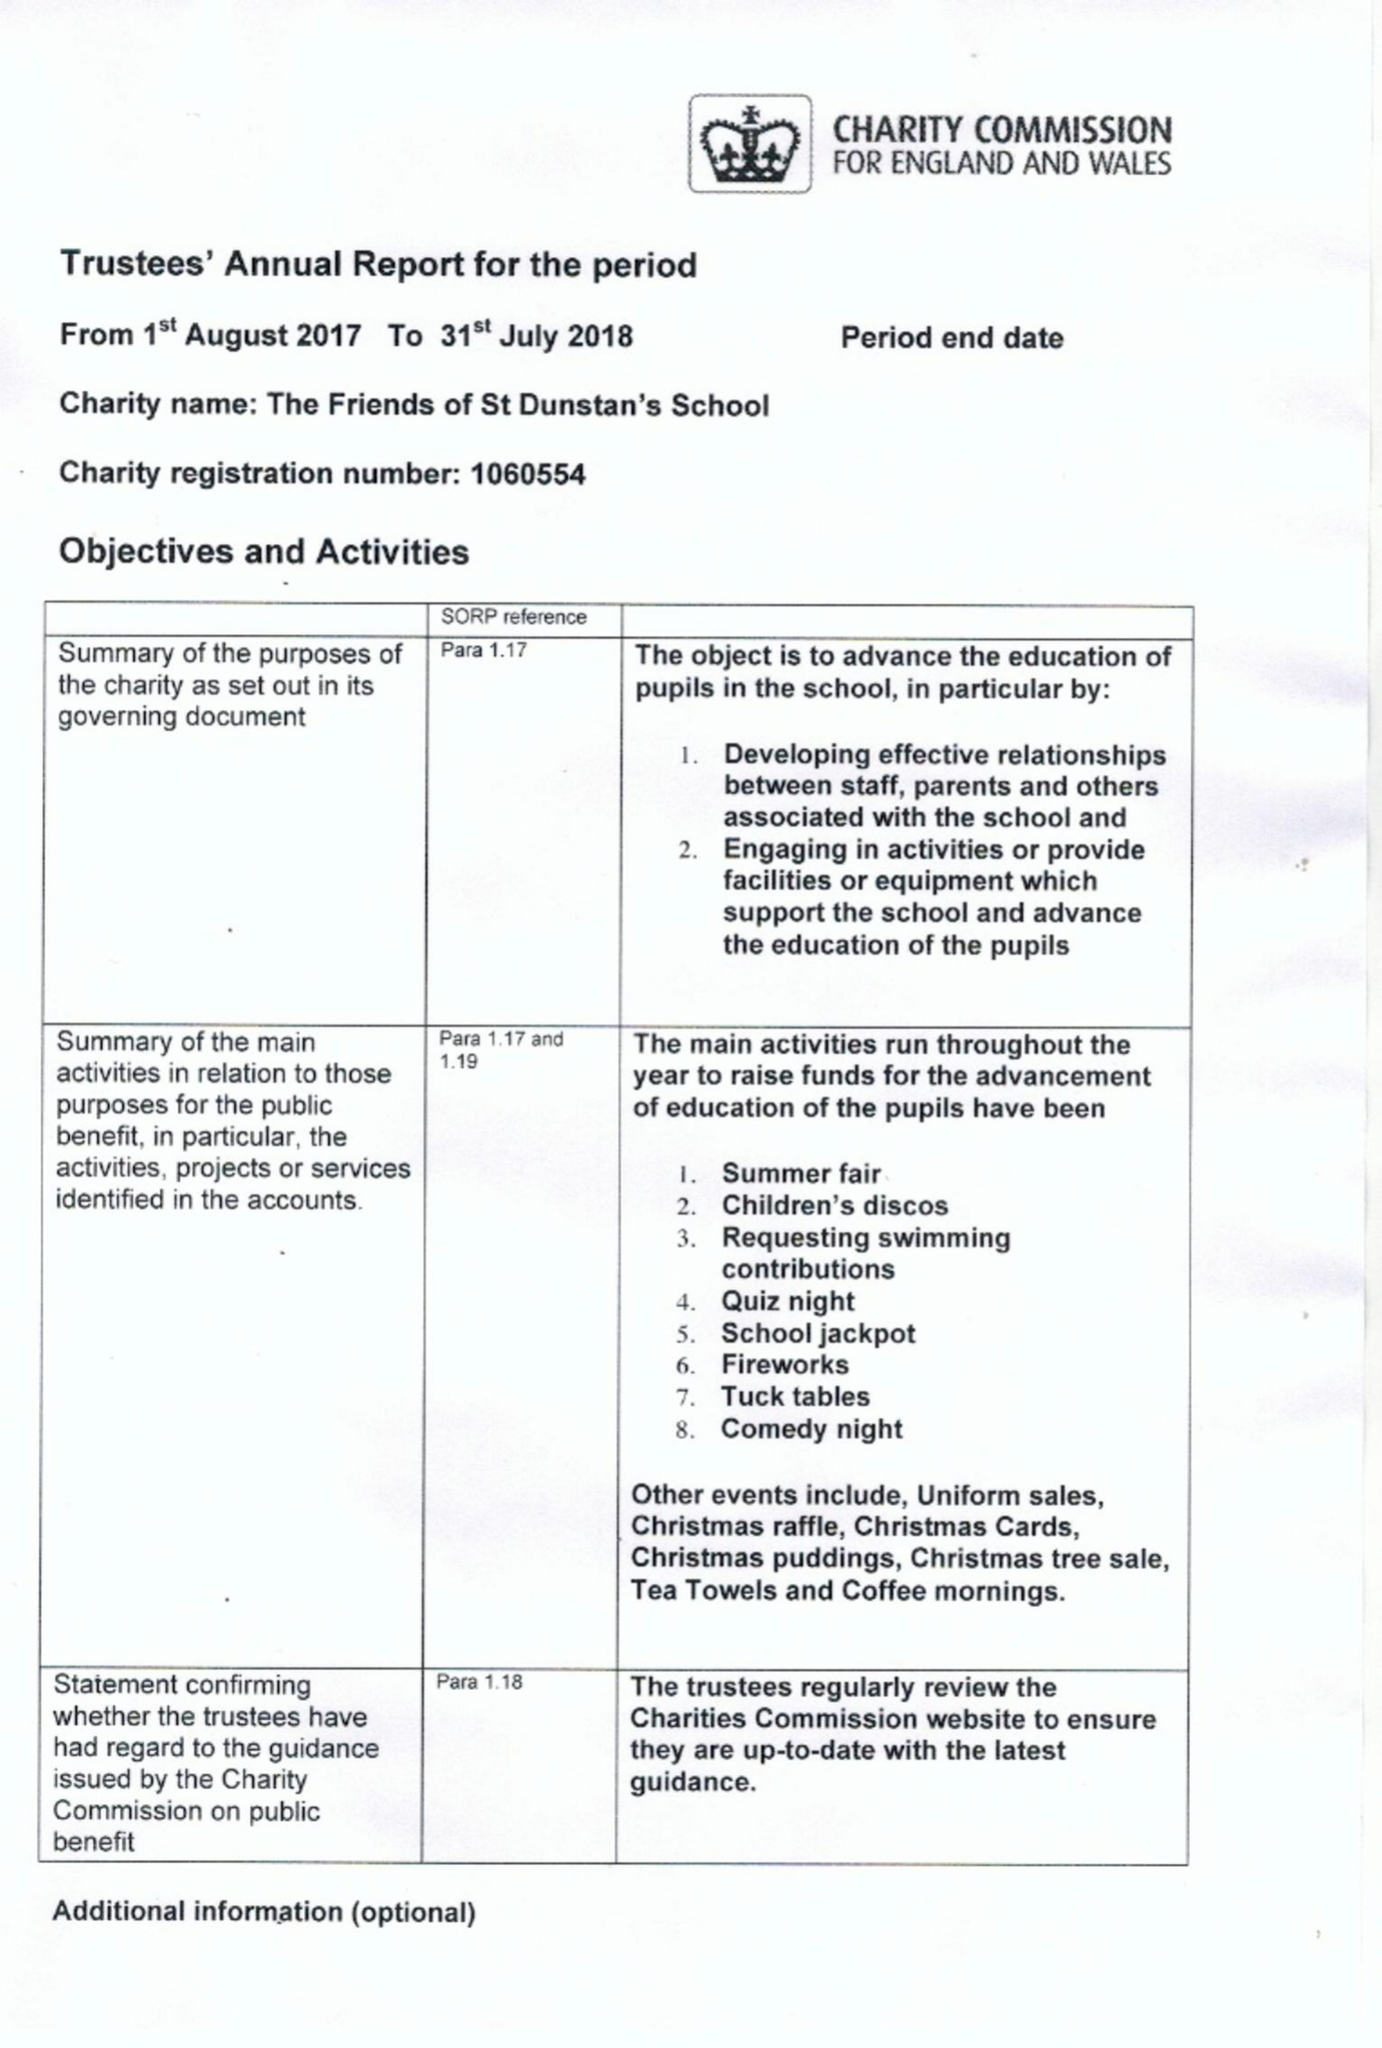What is the value for the charity_name?
Answer the question using a single word or phrase. The Friends Of St Dunstan's School 